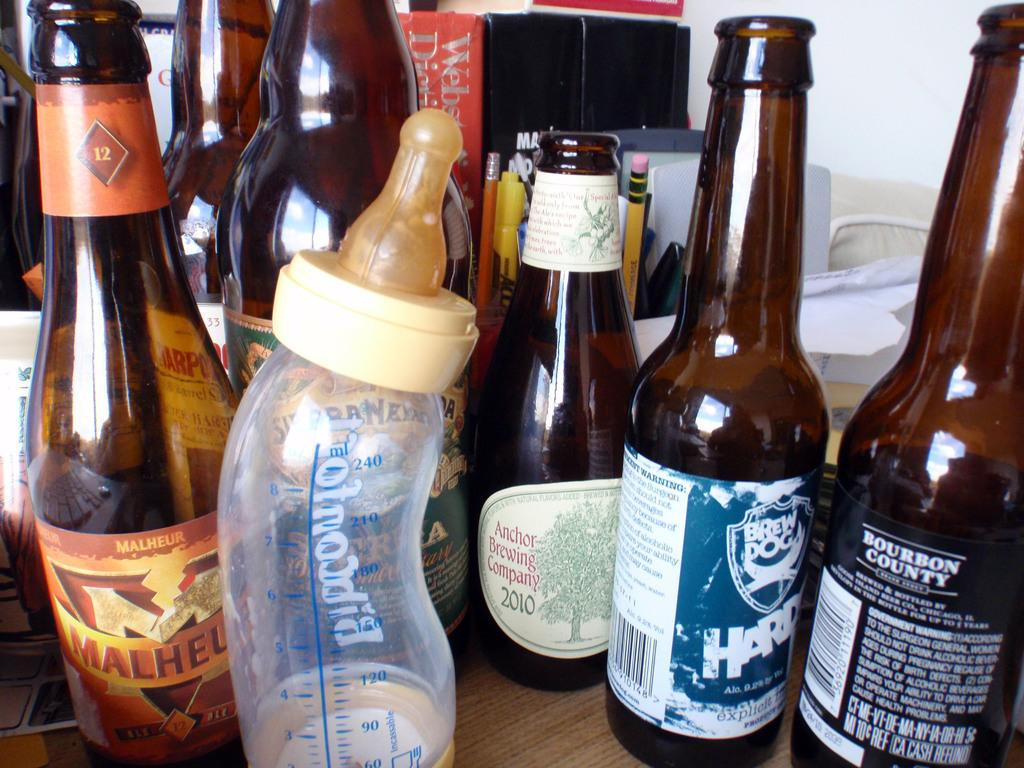Provide a one-sentence caption for the provided image. An infants bottle is left on a table  next to a bottle of Malheur. 